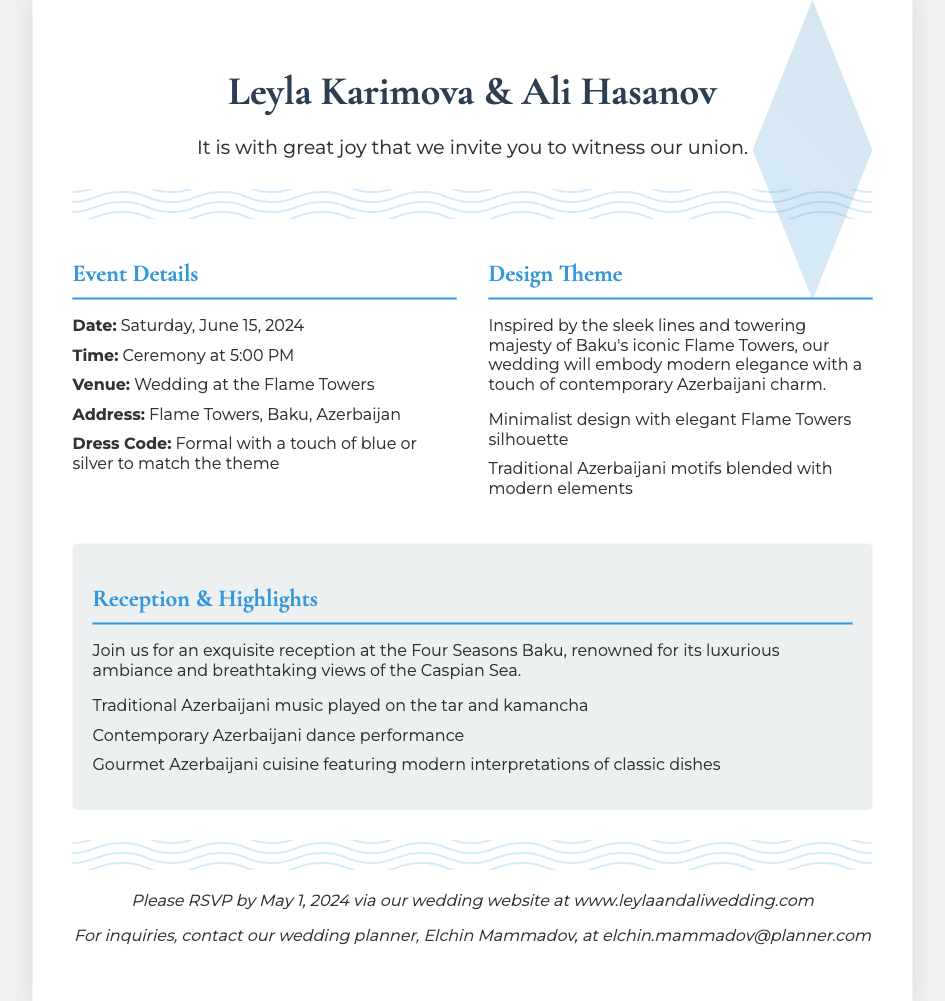What is the date of the wedding? The date of the wedding is mentioned in the event details section.
Answer: Saturday, June 15, 2024 What venue will the wedding take place at? The venue is specified in the event details of the invitation.
Answer: Flame Towers Who are the couple getting married? The names of the couple are stated at the top of the invitation.
Answer: Leyla Karimova & Ali Hasanov What is the dress code for the event? The dress code is outlined in the event details section.
Answer: Formal with a touch of blue or silver What is the theme of the wedding? The design theme is described in the design theme section of the invitation.
Answer: Modern elegance with a touch of contemporary Azerbaijani charm When is the RSVP deadline? The RSVP deadline is explicitly provided in the RSVP section of the invitation.
Answer: May 1, 2024 What type of music will be played at the reception? The type of music is listed under the reception highlights section.
Answer: Traditional Azerbaijani music played on the tar and kamancha Where will the reception be held? The location of the reception is mentioned in the reception highlights.
Answer: Four Seasons Baku What is the wedding planner's name? The name of the wedding planner is mentioned in the RSVP section.
Answer: Elchin Mammadov 